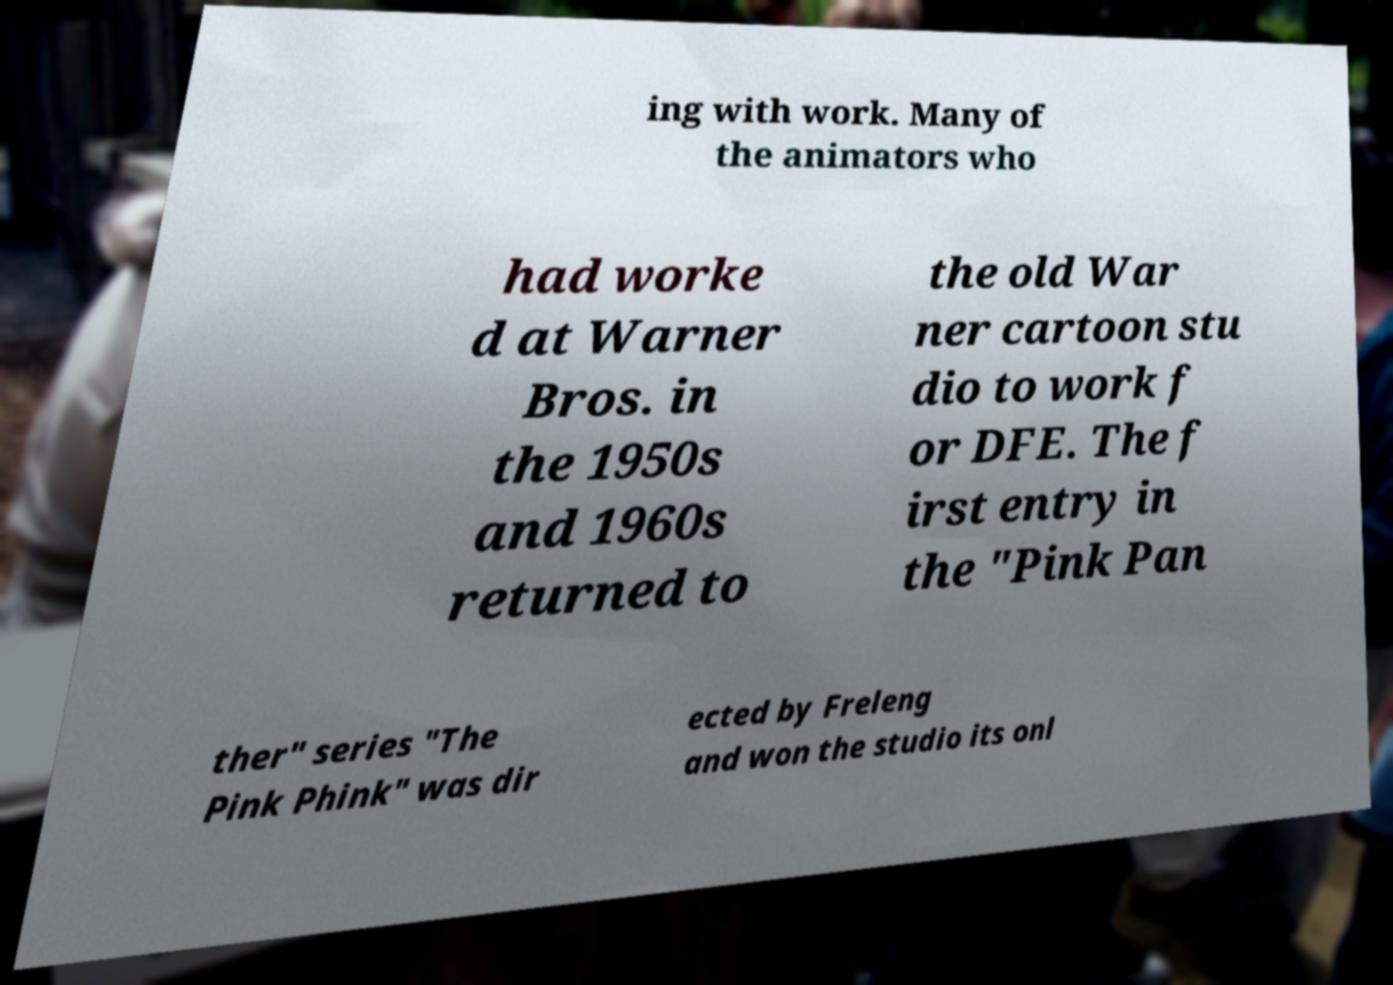Could you assist in decoding the text presented in this image and type it out clearly? ing with work. Many of the animators who had worke d at Warner Bros. in the 1950s and 1960s returned to the old War ner cartoon stu dio to work f or DFE. The f irst entry in the "Pink Pan ther" series "The Pink Phink" was dir ected by Freleng and won the studio its onl 